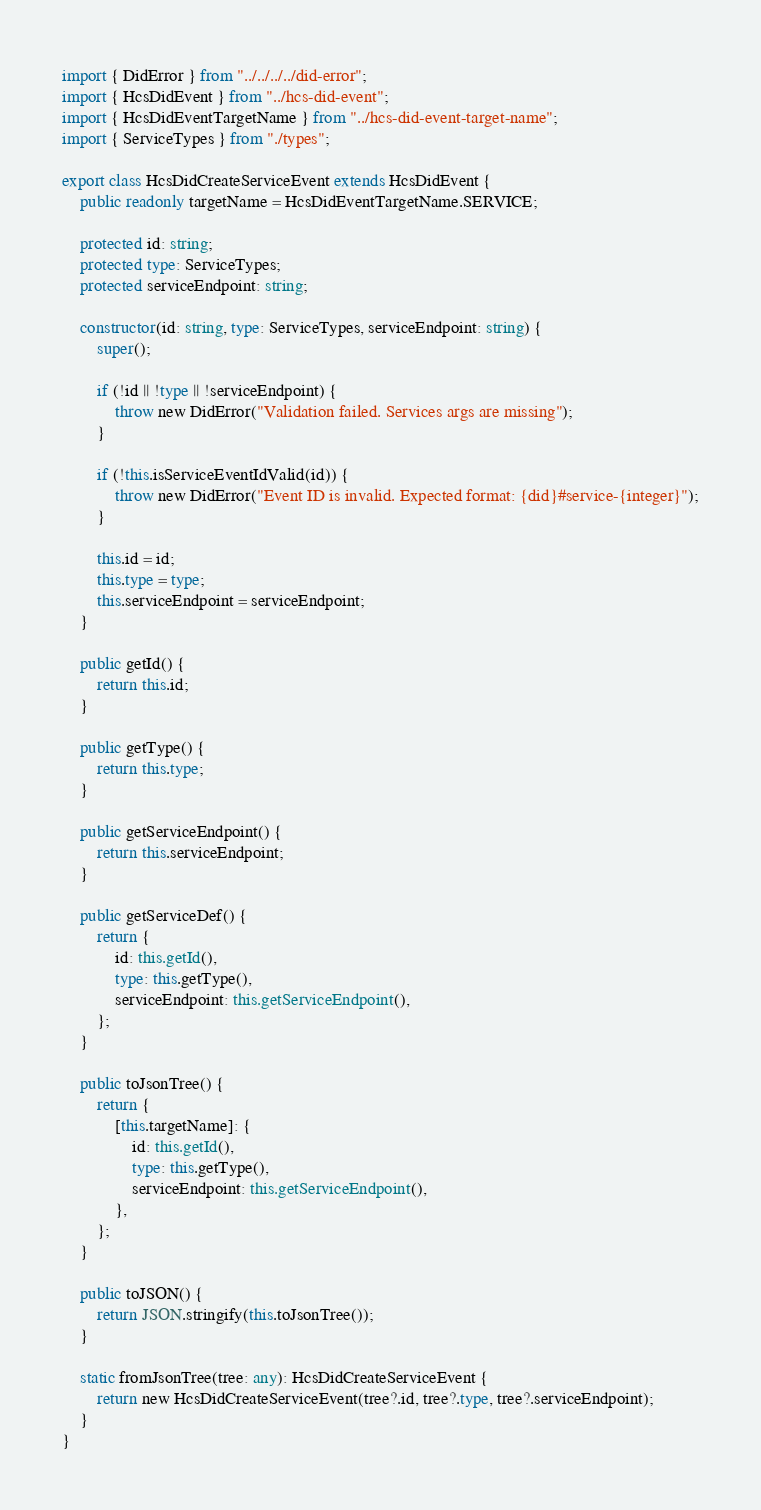Convert code to text. <code><loc_0><loc_0><loc_500><loc_500><_TypeScript_>import { DidError } from "../../../../did-error";
import { HcsDidEvent } from "../hcs-did-event";
import { HcsDidEventTargetName } from "../hcs-did-event-target-name";
import { ServiceTypes } from "./types";

export class HcsDidCreateServiceEvent extends HcsDidEvent {
    public readonly targetName = HcsDidEventTargetName.SERVICE;

    protected id: string;
    protected type: ServiceTypes;
    protected serviceEndpoint: string;

    constructor(id: string, type: ServiceTypes, serviceEndpoint: string) {
        super();

        if (!id || !type || !serviceEndpoint) {
            throw new DidError("Validation failed. Services args are missing");
        }

        if (!this.isServiceEventIdValid(id)) {
            throw new DidError("Event ID is invalid. Expected format: {did}#service-{integer}");
        }

        this.id = id;
        this.type = type;
        this.serviceEndpoint = serviceEndpoint;
    }

    public getId() {
        return this.id;
    }

    public getType() {
        return this.type;
    }

    public getServiceEndpoint() {
        return this.serviceEndpoint;
    }

    public getServiceDef() {
        return {
            id: this.getId(),
            type: this.getType(),
            serviceEndpoint: this.getServiceEndpoint(),
        };
    }

    public toJsonTree() {
        return {
            [this.targetName]: {
                id: this.getId(),
                type: this.getType(),
                serviceEndpoint: this.getServiceEndpoint(),
            },
        };
    }

    public toJSON() {
        return JSON.stringify(this.toJsonTree());
    }

    static fromJsonTree(tree: any): HcsDidCreateServiceEvent {
        return new HcsDidCreateServiceEvent(tree?.id, tree?.type, tree?.serviceEndpoint);
    }
}
</code> 